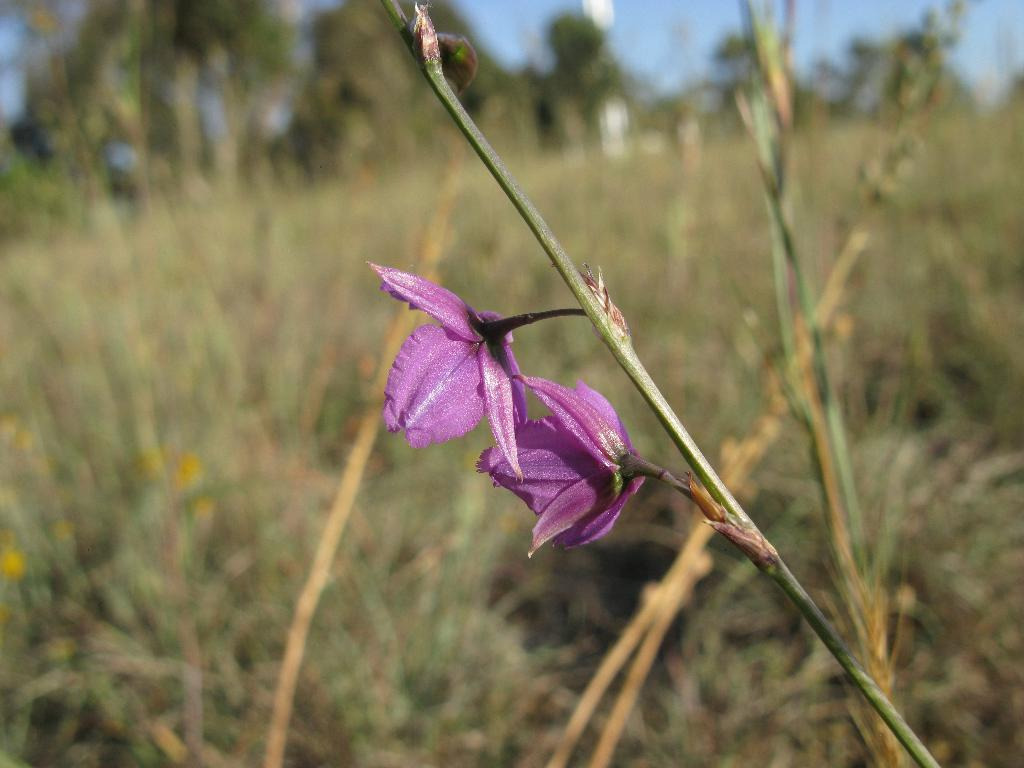What type of plant is in the image? There is a flower plant in the image. What color are the flowers on the plant? The flowers on the plant are purple. Can you describe the background of the image? The background of the image is blurred. What is the name of the daughter who is watering the plant in the image? There is no daughter present in the image, nor is there any indication of someone watering the plant. 